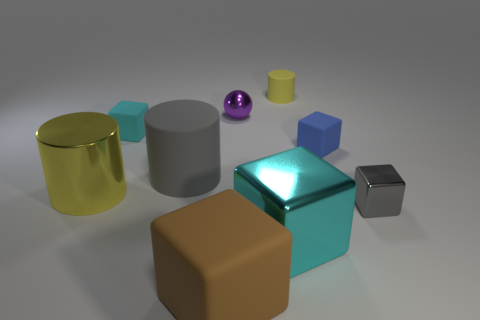There is a big thing that is the same color as the tiny shiny cube; what is its material?
Make the answer very short. Rubber. Do the big matte cylinder and the small matte cylinder have the same color?
Make the answer very short. No. Is the number of cyan shiny blocks on the left side of the blue object greater than the number of tiny yellow matte objects?
Keep it short and to the point. No. What is the size of the yellow rubber thing that is the same shape as the yellow metal thing?
Provide a succinct answer. Small. Is there anything else that is made of the same material as the tiny gray object?
Ensure brevity in your answer.  Yes. The brown rubber thing has what shape?
Give a very brief answer. Cube. What is the shape of the yellow metal object that is the same size as the brown rubber object?
Your answer should be compact. Cylinder. Are there any other things that have the same color as the tiny metallic block?
Your answer should be very brief. Yes. What size is the cyan cube that is made of the same material as the small gray cube?
Give a very brief answer. Large. There is a tiny purple shiny object; does it have the same shape as the rubber thing in front of the gray metal block?
Give a very brief answer. No. 